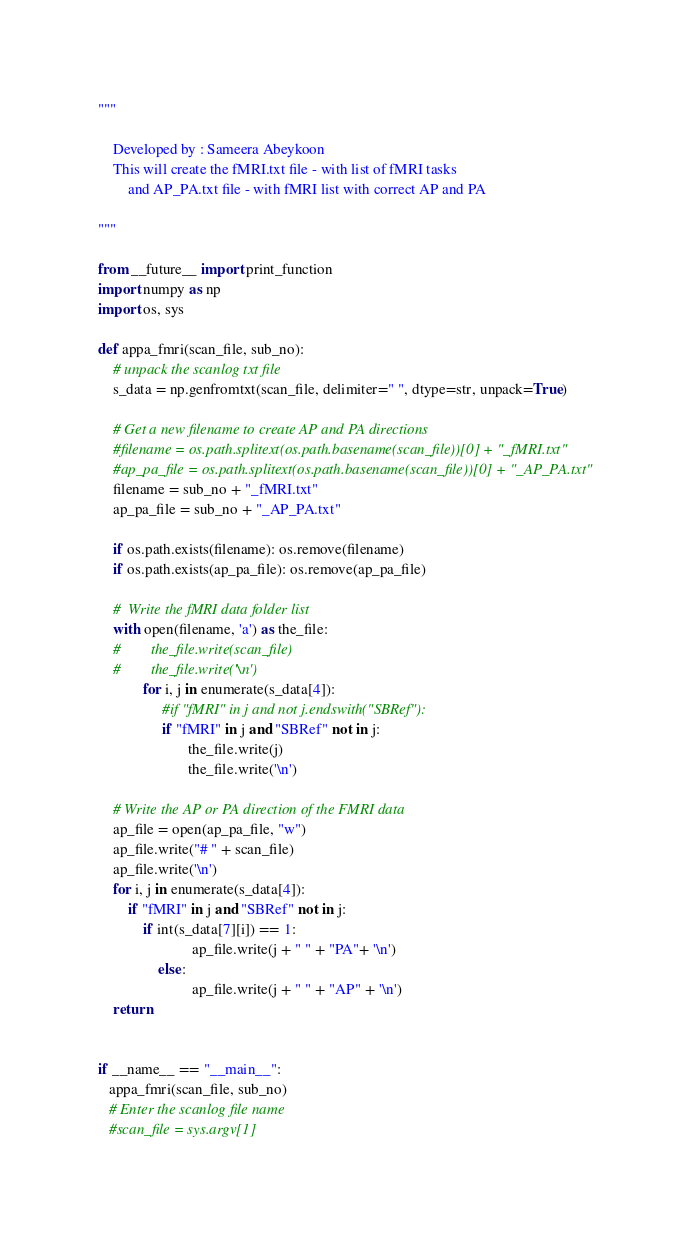Convert code to text. <code><loc_0><loc_0><loc_500><loc_500><_Python_>"""

	Developed by : Sameera Abeykoon
	This will create the fMRI.txt file - with list of fMRI tasks
        and AP_PA.txt file - with fMRI list with correct AP and PA 

"""

from __future__ import print_function
import numpy as np
import os, sys

def appa_fmri(scan_file, sub_no):	
    # unpack the scanlog txt file
    s_data = np.genfromtxt(scan_file, delimiter=" ", dtype=str, unpack=True)

    # Get a new filename to create AP and PA directions
    #filename = os.path.splitext(os.path.basename(scan_file))[0] + "_fMRI.txt"
    #ap_pa_file = os.path.splitext(os.path.basename(scan_file))[0] + "_AP_PA.txt"
    filename = sub_no + "_fMRI.txt"
    ap_pa_file = sub_no + "_AP_PA.txt"

    if os.path.exists(filename): os.remove(filename)
    if os.path.exists(ap_pa_file): os.remove(ap_pa_file)

    #  Write the fMRI data folder list
    with open(filename, 'a') as the_file:
    #        the_file.write(scan_file)
    #        the_file.write('\n')
            for i, j in enumerate(s_data[4]):
                 #if "fMRI" in j and not j.endswith("SBRef"):
                 if "fMRI" in j and "SBRef" not in j:
                        the_file.write(j)
                        the_file.write('\n')

    # Write the AP or PA direction of the FMRI data
    ap_file = open(ap_pa_file, "w")
    ap_file.write("# " + scan_file)
    ap_file.write('\n')
    for i, j in enumerate(s_data[4]):
    	if "fMRI" in j and "SBRef" not in j:
        	if int(s_data[7][i]) == 1:
                         ap_file.write(j + " " + "PA"+ '\n')
                else:
                         ap_file.write(j + " " + "AP" + '\n')
    return


if __name__ == "__main__":
   appa_fmri(scan_file, sub_no)
   # Enter the scanlog file name
   #scan_file = sys.argv[1]

</code> 